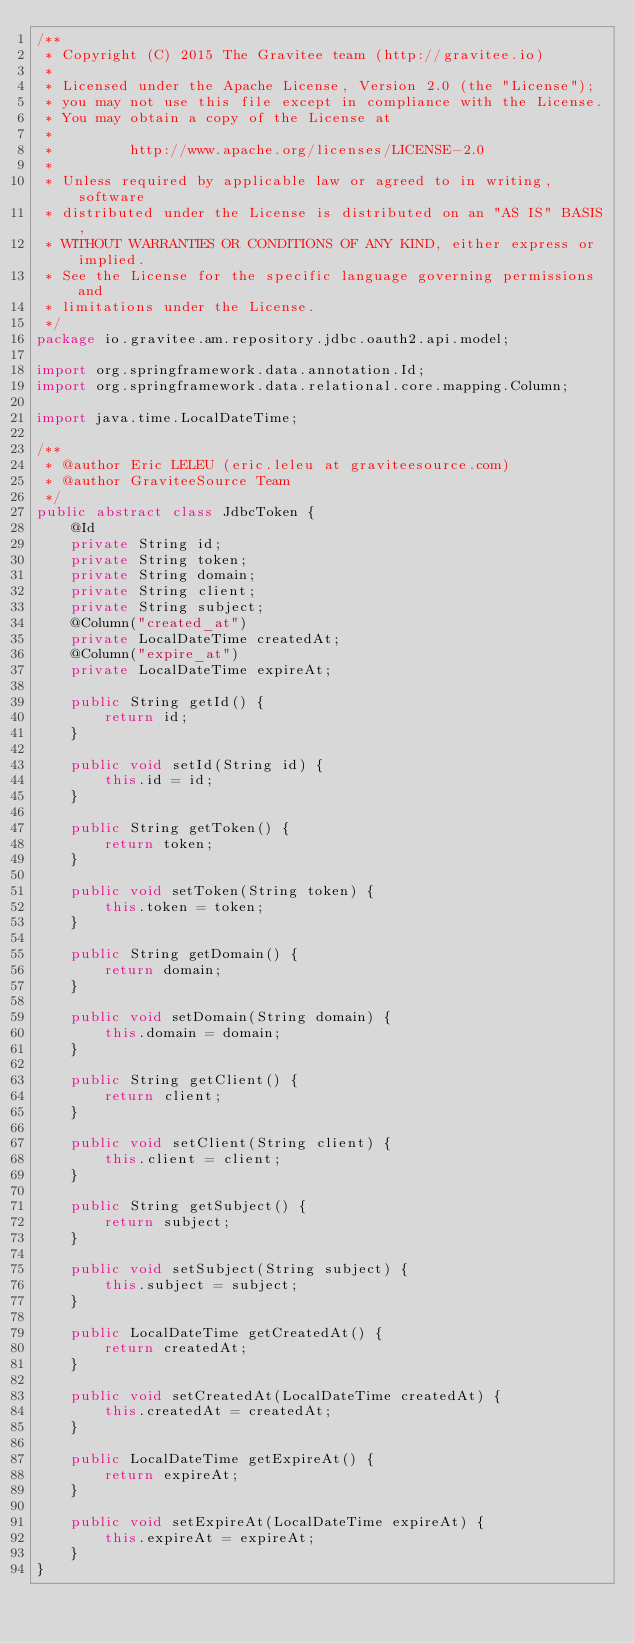Convert code to text. <code><loc_0><loc_0><loc_500><loc_500><_Java_>/**
 * Copyright (C) 2015 The Gravitee team (http://gravitee.io)
 *
 * Licensed under the Apache License, Version 2.0 (the "License");
 * you may not use this file except in compliance with the License.
 * You may obtain a copy of the License at
 *
 *         http://www.apache.org/licenses/LICENSE-2.0
 *
 * Unless required by applicable law or agreed to in writing, software
 * distributed under the License is distributed on an "AS IS" BASIS,
 * WITHOUT WARRANTIES OR CONDITIONS OF ANY KIND, either express or implied.
 * See the License for the specific language governing permissions and
 * limitations under the License.
 */
package io.gravitee.am.repository.jdbc.oauth2.api.model;

import org.springframework.data.annotation.Id;
import org.springframework.data.relational.core.mapping.Column;

import java.time.LocalDateTime;

/**
 * @author Eric LELEU (eric.leleu at graviteesource.com)
 * @author GraviteeSource Team
 */
public abstract class JdbcToken {
    @Id
    private String id;
    private String token;
    private String domain;
    private String client;
    private String subject;
    @Column("created_at")
    private LocalDateTime createdAt;
    @Column("expire_at")
    private LocalDateTime expireAt;

    public String getId() {
        return id;
    }

    public void setId(String id) {
        this.id = id;
    }

    public String getToken() {
        return token;
    }

    public void setToken(String token) {
        this.token = token;
    }

    public String getDomain() {
        return domain;
    }

    public void setDomain(String domain) {
        this.domain = domain;
    }

    public String getClient() {
        return client;
    }

    public void setClient(String client) {
        this.client = client;
    }

    public String getSubject() {
        return subject;
    }

    public void setSubject(String subject) {
        this.subject = subject;
    }

    public LocalDateTime getCreatedAt() {
        return createdAt;
    }

    public void setCreatedAt(LocalDateTime createdAt) {
        this.createdAt = createdAt;
    }

    public LocalDateTime getExpireAt() {
        return expireAt;
    }

    public void setExpireAt(LocalDateTime expireAt) {
        this.expireAt = expireAt;
    }
}
</code> 